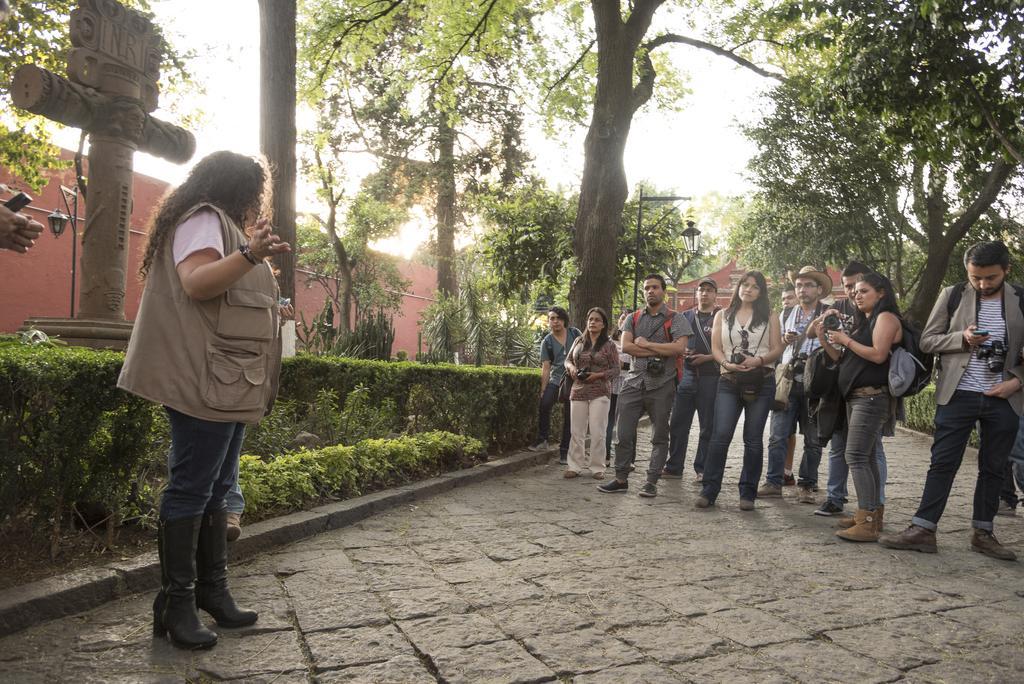Can you describe this image briefly? As we can see in the image there are few people here and there, plants, trees, street lamp and buildings. Few of them are holding cameras in their hands. 